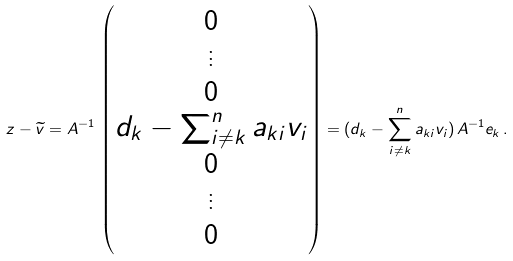<formula> <loc_0><loc_0><loc_500><loc_500>z - \widetilde { v } = A ^ { - 1 } \, \begin{pmatrix} 0 \\ \vdots \\ 0 \\ d _ { k } - \sum _ { i \neq k } ^ { n } a _ { k i } v _ { i } \\ 0 \\ \vdots \\ 0 \end{pmatrix} = ( d _ { k } - \sum _ { i \neq k } ^ { n } a _ { k i } v _ { i } ) \, A ^ { - 1 } e _ { k } \, .</formula> 